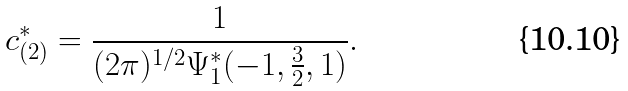Convert formula to latex. <formula><loc_0><loc_0><loc_500><loc_500>c _ { ( 2 ) } ^ { \ast } = \frac { 1 } { ( 2 \pi ) ^ { 1 / 2 } \Psi _ { 1 } ^ { \ast } ( - 1 , \frac { 3 } { 2 } , 1 ) } .</formula> 